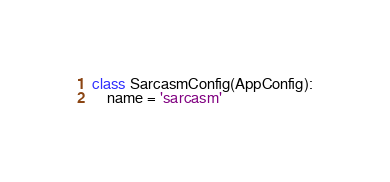Convert code to text. <code><loc_0><loc_0><loc_500><loc_500><_Python_>

class SarcasmConfig(AppConfig):
    name = 'sarcasm'
</code> 